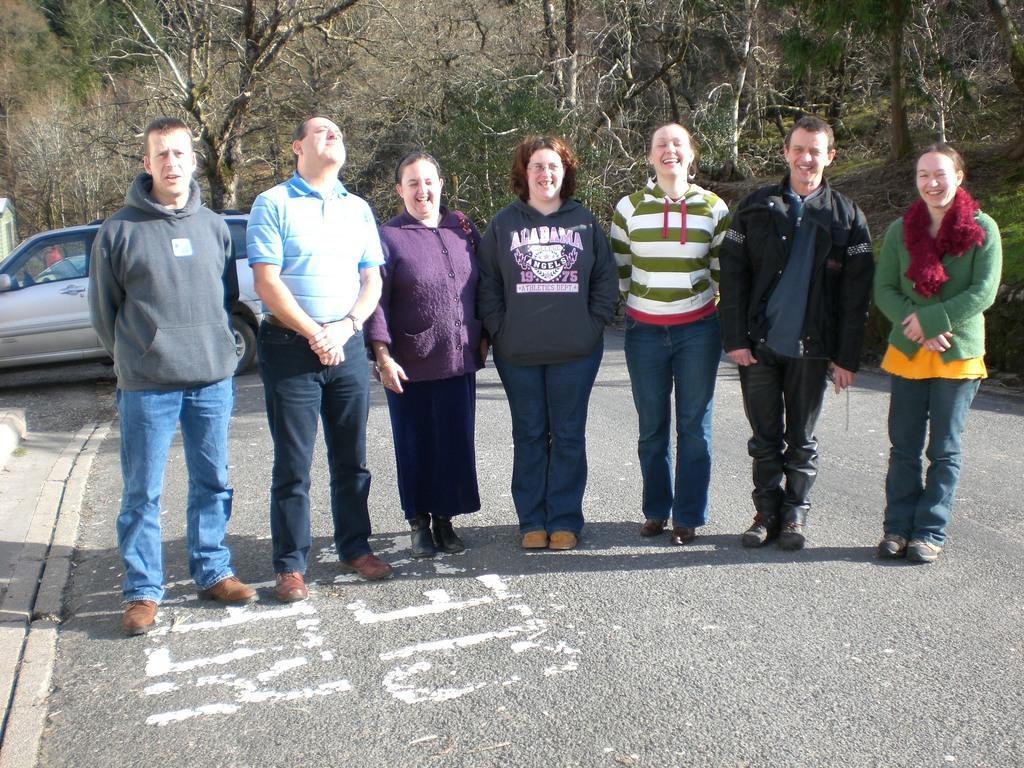Can you describe this image briefly? In this picture, we see three men and four women are standing. All of them are smiling and they are posing for the photo. At the bottom, we see the road. Behind them, we see a car parked on the road. There are trees in the background. 